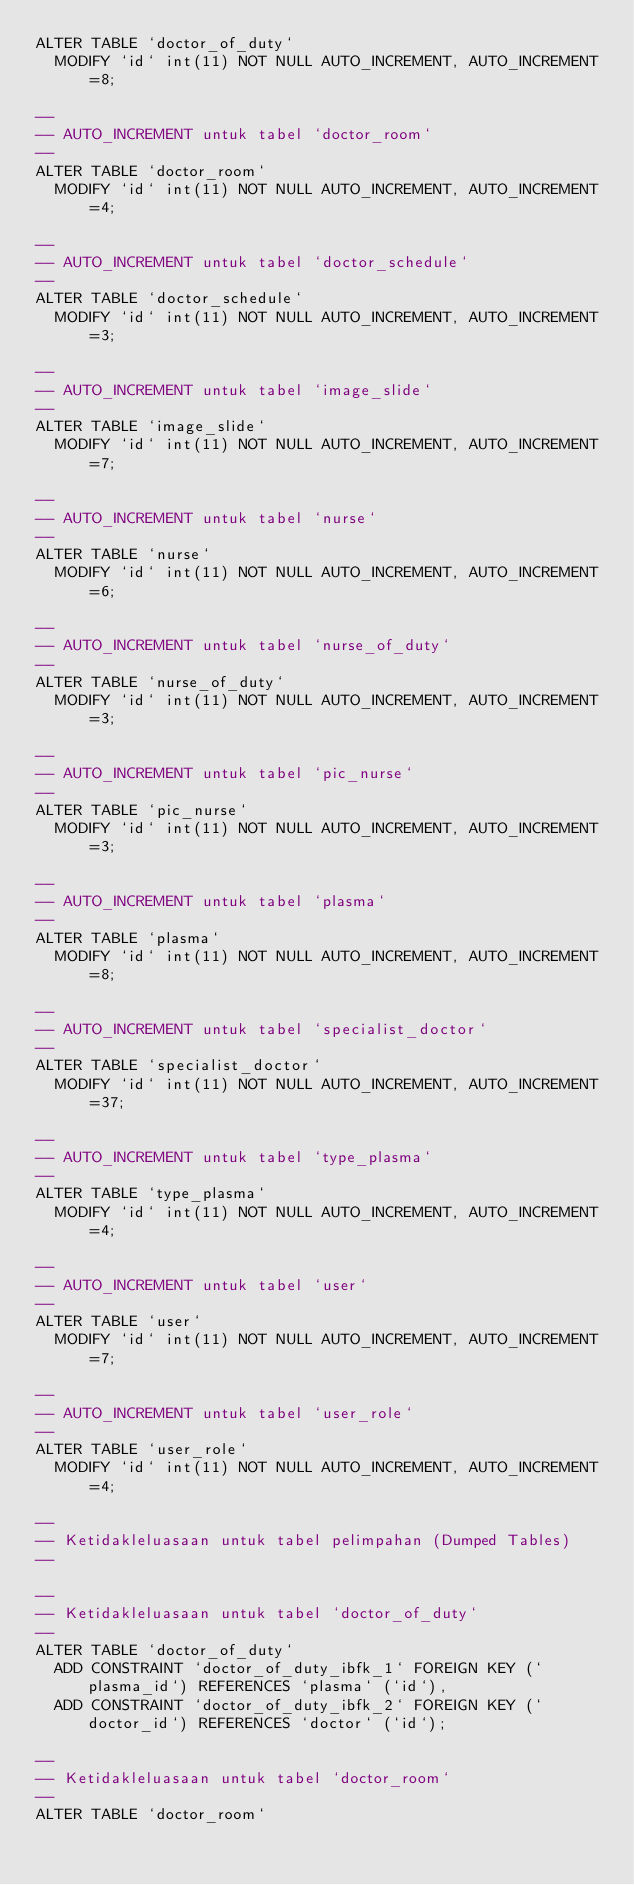<code> <loc_0><loc_0><loc_500><loc_500><_SQL_>ALTER TABLE `doctor_of_duty`
  MODIFY `id` int(11) NOT NULL AUTO_INCREMENT, AUTO_INCREMENT=8;

--
-- AUTO_INCREMENT untuk tabel `doctor_room`
--
ALTER TABLE `doctor_room`
  MODIFY `id` int(11) NOT NULL AUTO_INCREMENT, AUTO_INCREMENT=4;

--
-- AUTO_INCREMENT untuk tabel `doctor_schedule`
--
ALTER TABLE `doctor_schedule`
  MODIFY `id` int(11) NOT NULL AUTO_INCREMENT, AUTO_INCREMENT=3;

--
-- AUTO_INCREMENT untuk tabel `image_slide`
--
ALTER TABLE `image_slide`
  MODIFY `id` int(11) NOT NULL AUTO_INCREMENT, AUTO_INCREMENT=7;

--
-- AUTO_INCREMENT untuk tabel `nurse`
--
ALTER TABLE `nurse`
  MODIFY `id` int(11) NOT NULL AUTO_INCREMENT, AUTO_INCREMENT=6;

--
-- AUTO_INCREMENT untuk tabel `nurse_of_duty`
--
ALTER TABLE `nurse_of_duty`
  MODIFY `id` int(11) NOT NULL AUTO_INCREMENT, AUTO_INCREMENT=3;

--
-- AUTO_INCREMENT untuk tabel `pic_nurse`
--
ALTER TABLE `pic_nurse`
  MODIFY `id` int(11) NOT NULL AUTO_INCREMENT, AUTO_INCREMENT=3;

--
-- AUTO_INCREMENT untuk tabel `plasma`
--
ALTER TABLE `plasma`
  MODIFY `id` int(11) NOT NULL AUTO_INCREMENT, AUTO_INCREMENT=8;

--
-- AUTO_INCREMENT untuk tabel `specialist_doctor`
--
ALTER TABLE `specialist_doctor`
  MODIFY `id` int(11) NOT NULL AUTO_INCREMENT, AUTO_INCREMENT=37;

--
-- AUTO_INCREMENT untuk tabel `type_plasma`
--
ALTER TABLE `type_plasma`
  MODIFY `id` int(11) NOT NULL AUTO_INCREMENT, AUTO_INCREMENT=4;

--
-- AUTO_INCREMENT untuk tabel `user`
--
ALTER TABLE `user`
  MODIFY `id` int(11) NOT NULL AUTO_INCREMENT, AUTO_INCREMENT=7;

--
-- AUTO_INCREMENT untuk tabel `user_role`
--
ALTER TABLE `user_role`
  MODIFY `id` int(11) NOT NULL AUTO_INCREMENT, AUTO_INCREMENT=4;

--
-- Ketidakleluasaan untuk tabel pelimpahan (Dumped Tables)
--

--
-- Ketidakleluasaan untuk tabel `doctor_of_duty`
--
ALTER TABLE `doctor_of_duty`
  ADD CONSTRAINT `doctor_of_duty_ibfk_1` FOREIGN KEY (`plasma_id`) REFERENCES `plasma` (`id`),
  ADD CONSTRAINT `doctor_of_duty_ibfk_2` FOREIGN KEY (`doctor_id`) REFERENCES `doctor` (`id`);

--
-- Ketidakleluasaan untuk tabel `doctor_room`
--
ALTER TABLE `doctor_room`</code> 